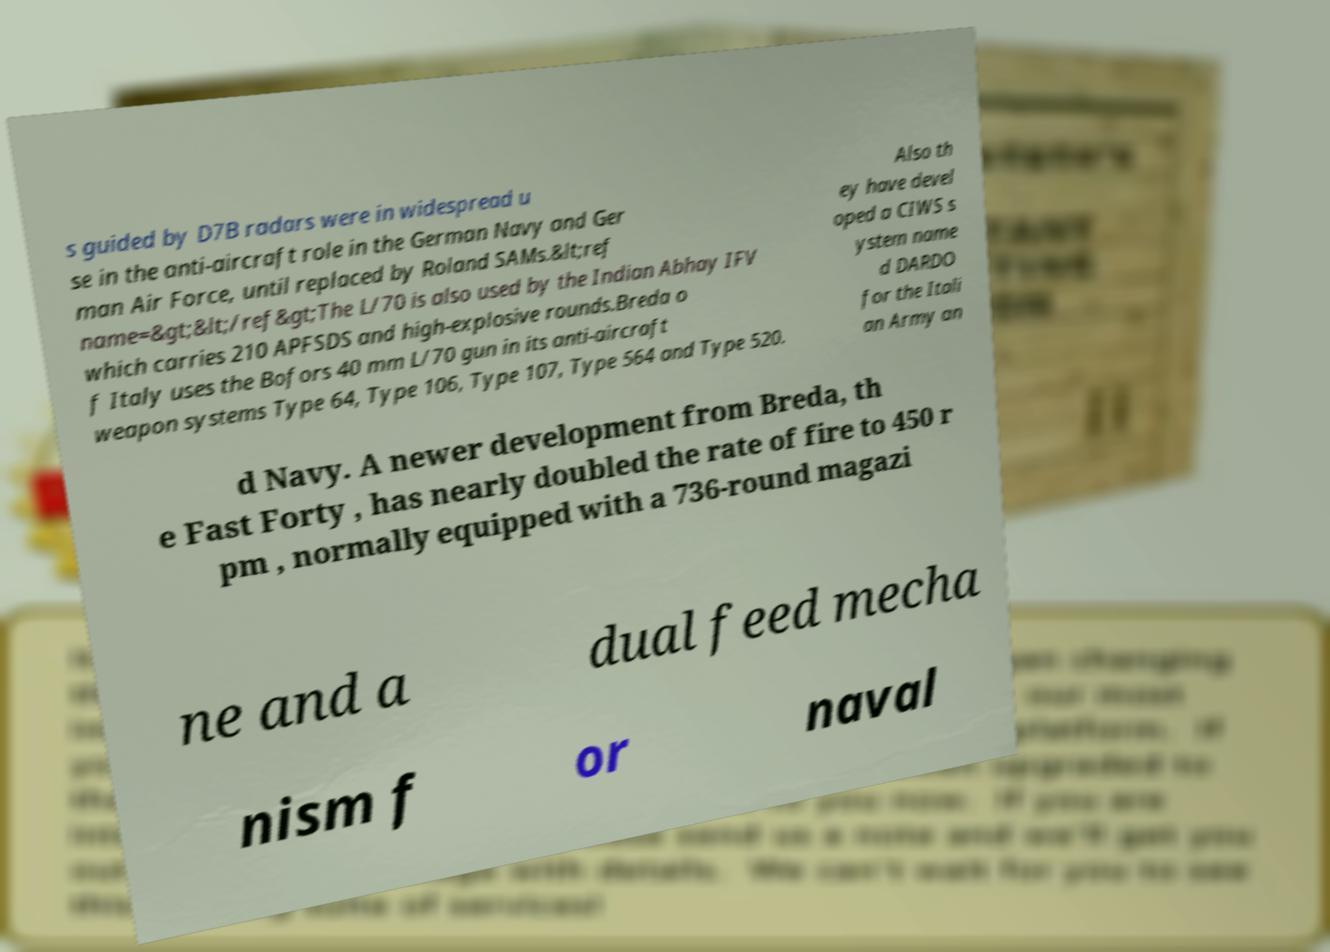I need the written content from this picture converted into text. Can you do that? s guided by D7B radars were in widespread u se in the anti-aircraft role in the German Navy and Ger man Air Force, until replaced by Roland SAMs.&lt;ref name=&gt;&lt;/ref&gt;The L/70 is also used by the Indian Abhay IFV which carries 210 APFSDS and high-explosive rounds.Breda o f Italy uses the Bofors 40 mm L/70 gun in its anti-aircraft weapon systems Type 64, Type 106, Type 107, Type 564 and Type 520. Also th ey have devel oped a CIWS s ystem name d DARDO for the Itali an Army an d Navy. A newer development from Breda, th e Fast Forty , has nearly doubled the rate of fire to 450 r pm , normally equipped with a 736-round magazi ne and a dual feed mecha nism f or naval 